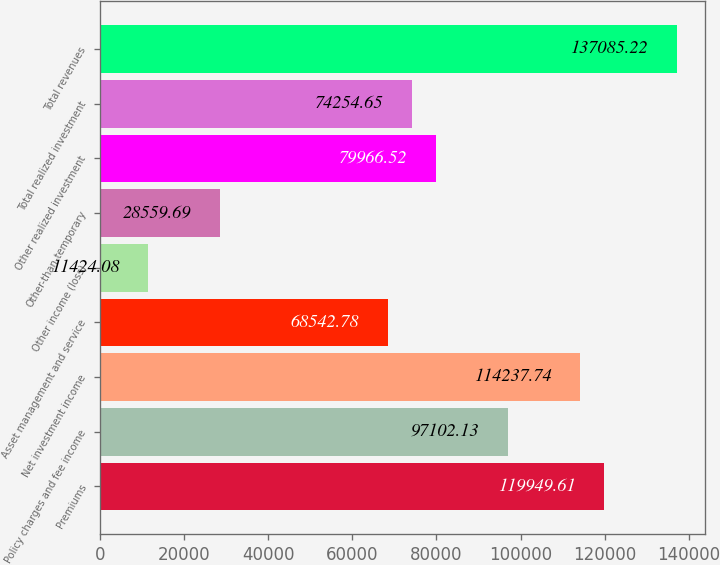Convert chart to OTSL. <chart><loc_0><loc_0><loc_500><loc_500><bar_chart><fcel>Premiums<fcel>Policy charges and fee income<fcel>Net investment income<fcel>Asset management and service<fcel>Other income (loss)<fcel>Other-than-temporary<fcel>Other realized investment<fcel>Total realized investment<fcel>Total revenues<nl><fcel>119950<fcel>97102.1<fcel>114238<fcel>68542.8<fcel>11424.1<fcel>28559.7<fcel>79966.5<fcel>74254.6<fcel>137085<nl></chart> 